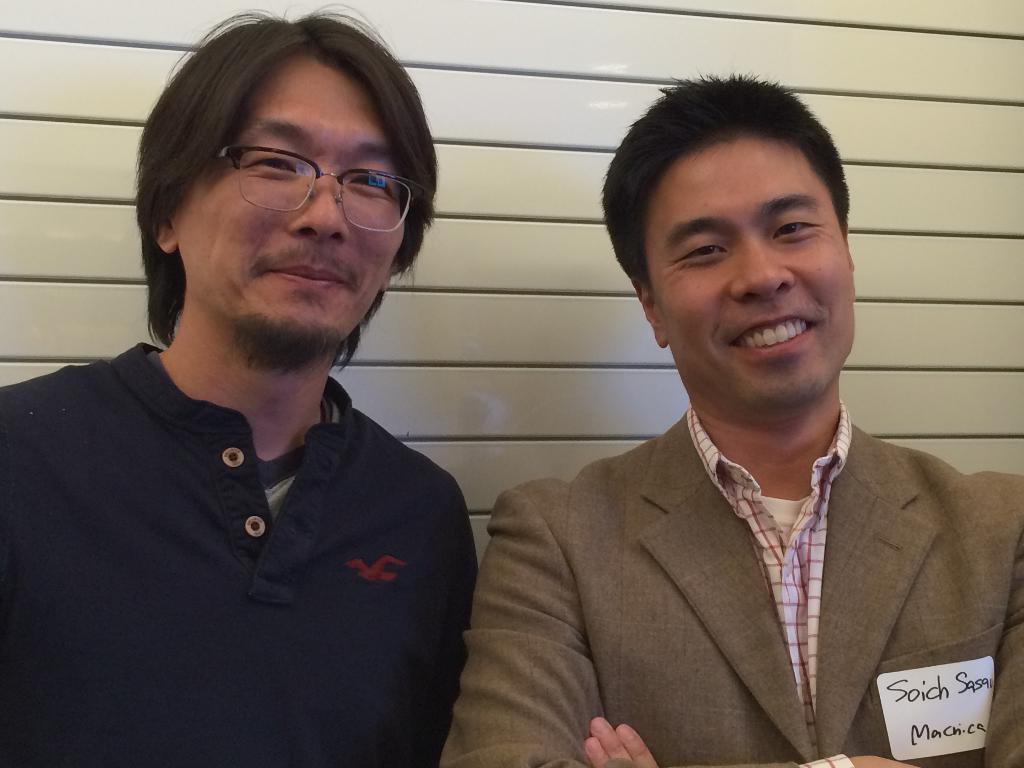Could you give a brief overview of what you see in this image? In this image I can see two people standing and posing for the picture. The person standing on the right hand side is wearing a suit with a label with some text on his pocket.  